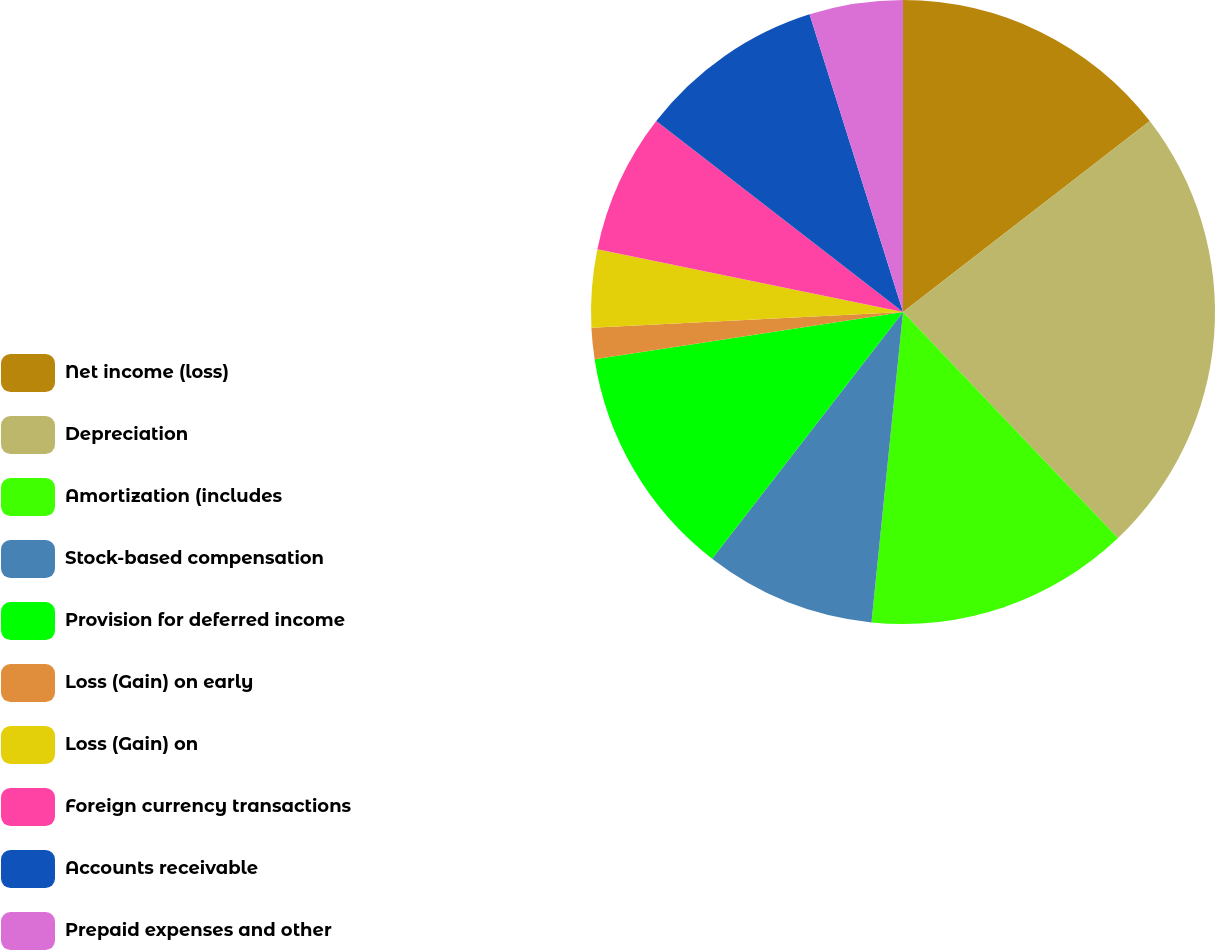<chart> <loc_0><loc_0><loc_500><loc_500><pie_chart><fcel>Net income (loss)<fcel>Depreciation<fcel>Amortization (includes<fcel>Stock-based compensation<fcel>Provision for deferred income<fcel>Loss (Gain) on early<fcel>Loss (Gain) on<fcel>Foreign currency transactions<fcel>Accounts receivable<fcel>Prepaid expenses and other<nl><fcel>14.52%<fcel>23.38%<fcel>13.71%<fcel>8.87%<fcel>12.1%<fcel>1.61%<fcel>4.03%<fcel>7.26%<fcel>9.68%<fcel>4.84%<nl></chart> 